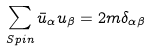Convert formula to latex. <formula><loc_0><loc_0><loc_500><loc_500>\sum _ { S p i n } \bar { u } _ { \alpha } u _ { \beta } = 2 m \delta _ { \alpha \beta }</formula> 